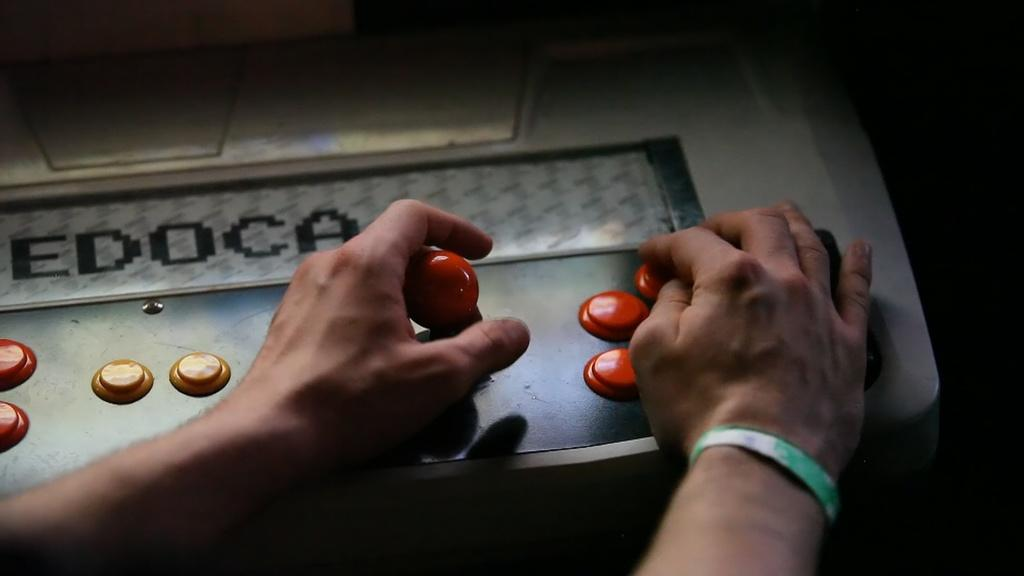What is on the grey surface in the image? There are buttons on a grey surface in the image. What is interacting with the buttons? There are hands on the buttons. What can be seen in the background of the image? The background of the image is dark. What type of laborer is depicted in the image? There is no laborer depicted in the image; it only shows buttons and hands on them. What is the mind doing in the image? The mind is not visible in the image, as it is an abstract concept and not something that can be seen. 